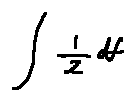<formula> <loc_0><loc_0><loc_500><loc_500>\int \frac { l } { z } d f</formula> 